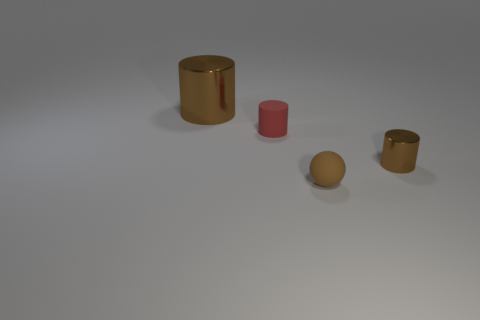There is a red rubber cylinder; does it have the same size as the metal cylinder in front of the big metal cylinder?
Provide a succinct answer. Yes. What color is the object that is both left of the small brown rubber ball and in front of the large brown shiny cylinder?
Offer a very short reply. Red. What number of objects are objects that are to the right of the big brown metallic cylinder or brown objects to the right of the small brown ball?
Provide a succinct answer. 3. What color is the object in front of the shiny cylinder in front of the shiny cylinder that is behind the tiny brown metallic cylinder?
Your answer should be very brief. Brown. Is there another matte object that has the same shape as the tiny red rubber object?
Offer a terse response. No. What number of purple blocks are there?
Offer a very short reply. 0. What is the shape of the big thing?
Offer a very short reply. Cylinder. What number of brown shiny things are the same size as the ball?
Your answer should be very brief. 1. Is the small red matte object the same shape as the tiny metal thing?
Provide a short and direct response. Yes. What is the color of the cylinder in front of the matte object behind the brown matte thing?
Make the answer very short. Brown. 